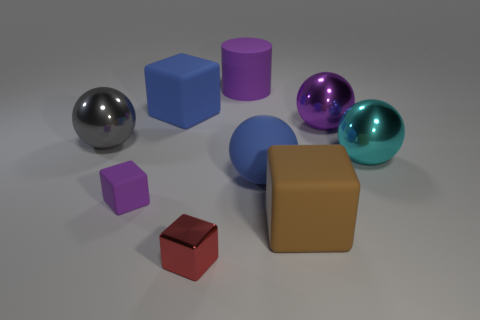Is the color of the big rubber cylinder the same as the large rubber thing that is in front of the purple matte block?
Offer a very short reply. No. There is a matte thing that is both in front of the big gray metallic object and behind the small purple rubber block; what size is it?
Your answer should be very brief. Large. There is a large brown cube; are there any big blue rubber balls on the left side of it?
Your answer should be compact. Yes. Is there a tiny red thing that is behind the blue matte thing behind the large cyan shiny thing?
Give a very brief answer. No. Are there an equal number of red blocks that are behind the big cyan ball and blue cubes behind the purple rubber cylinder?
Offer a terse response. Yes. There is a cylinder that is the same material as the blue ball; what is its color?
Your answer should be very brief. Purple. Are there any large cyan objects made of the same material as the purple cube?
Offer a terse response. No. What number of objects are large red balls or tiny rubber objects?
Your answer should be compact. 1. Does the gray thing have the same material as the large purple thing that is on the right side of the large brown matte cube?
Make the answer very short. Yes. There is a block that is behind the cyan sphere; how big is it?
Give a very brief answer. Large. 